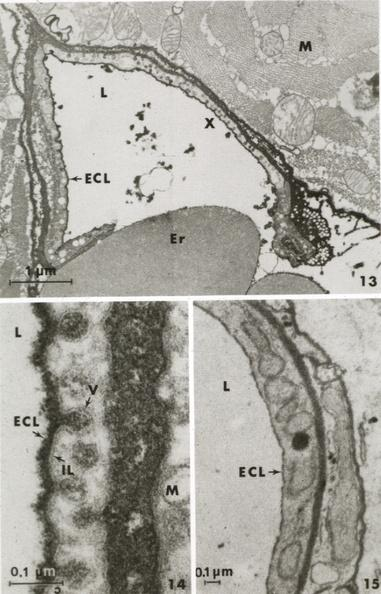s typical tuberculous exudate present?
Answer the question using a single word or phrase. No 